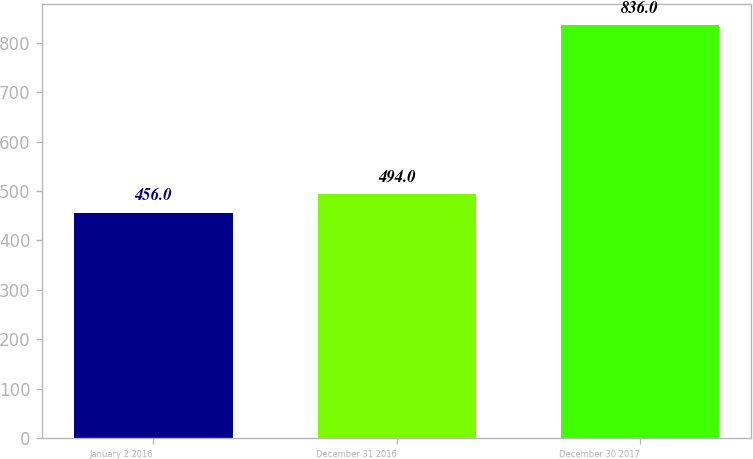<chart> <loc_0><loc_0><loc_500><loc_500><bar_chart><fcel>January 2 2016<fcel>December 31 2016<fcel>December 30 2017<nl><fcel>456<fcel>494<fcel>836<nl></chart> 